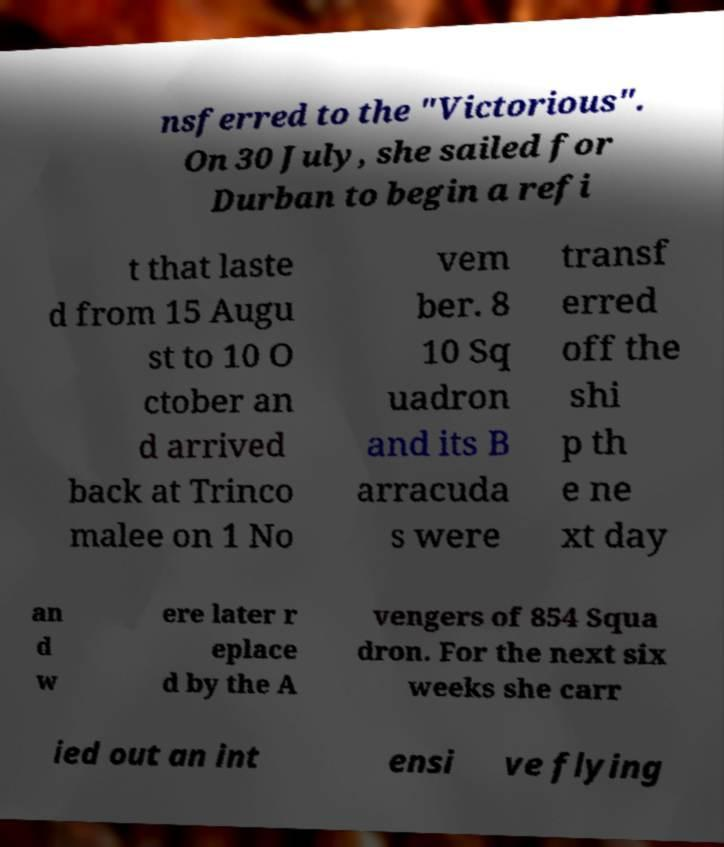Please read and relay the text visible in this image. What does it say? nsferred to the "Victorious". On 30 July, she sailed for Durban to begin a refi t that laste d from 15 Augu st to 10 O ctober an d arrived back at Trinco malee on 1 No vem ber. 8 10 Sq uadron and its B arracuda s were transf erred off the shi p th e ne xt day an d w ere later r eplace d by the A vengers of 854 Squa dron. For the next six weeks she carr ied out an int ensi ve flying 